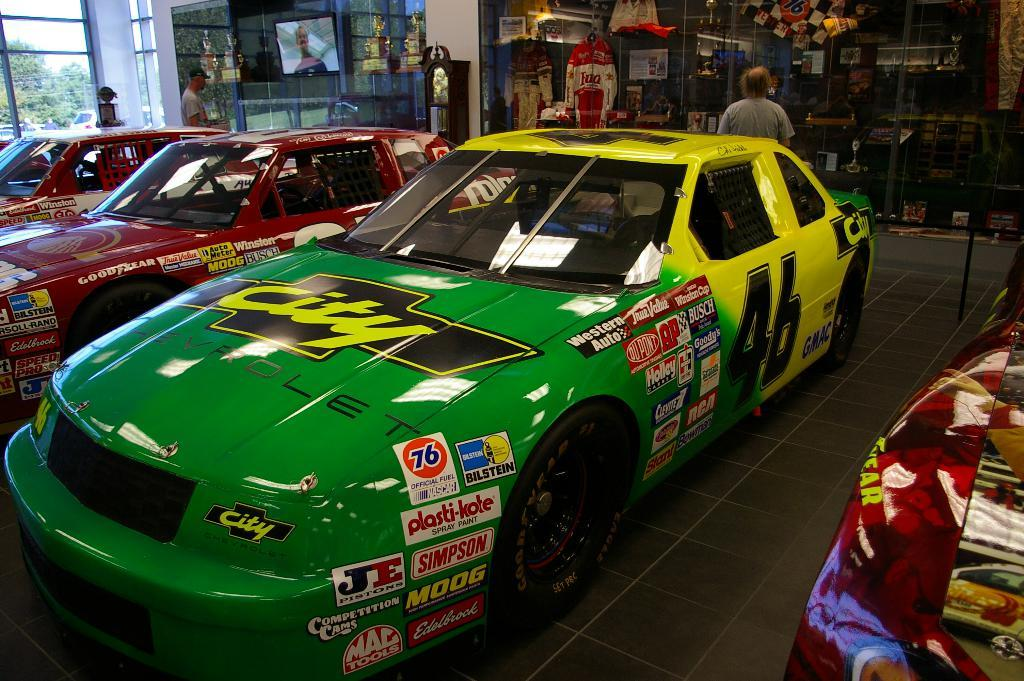Provide a one-sentence caption for the provided image. The green and yellow number 46 race car is displayed in a building. 